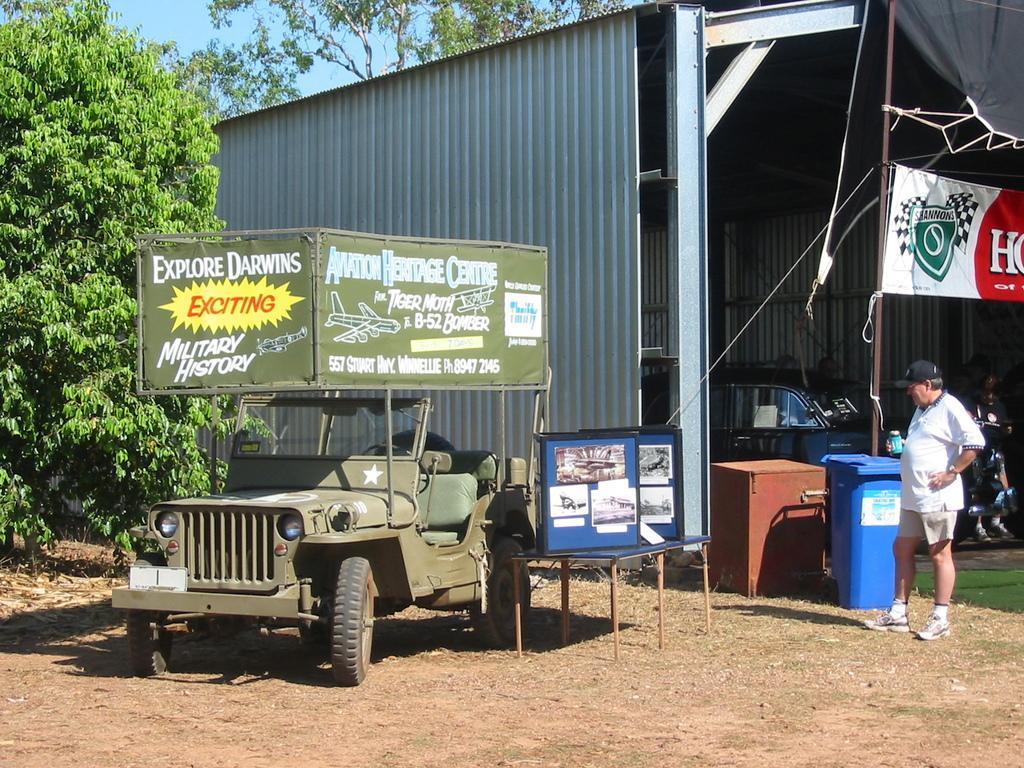Describe this image in one or two sentences. In this image we can see a shed under which there is a car, person and beside there is vehicle to which there is a board and a table on which there are some boards and around there are some trees and plants. 